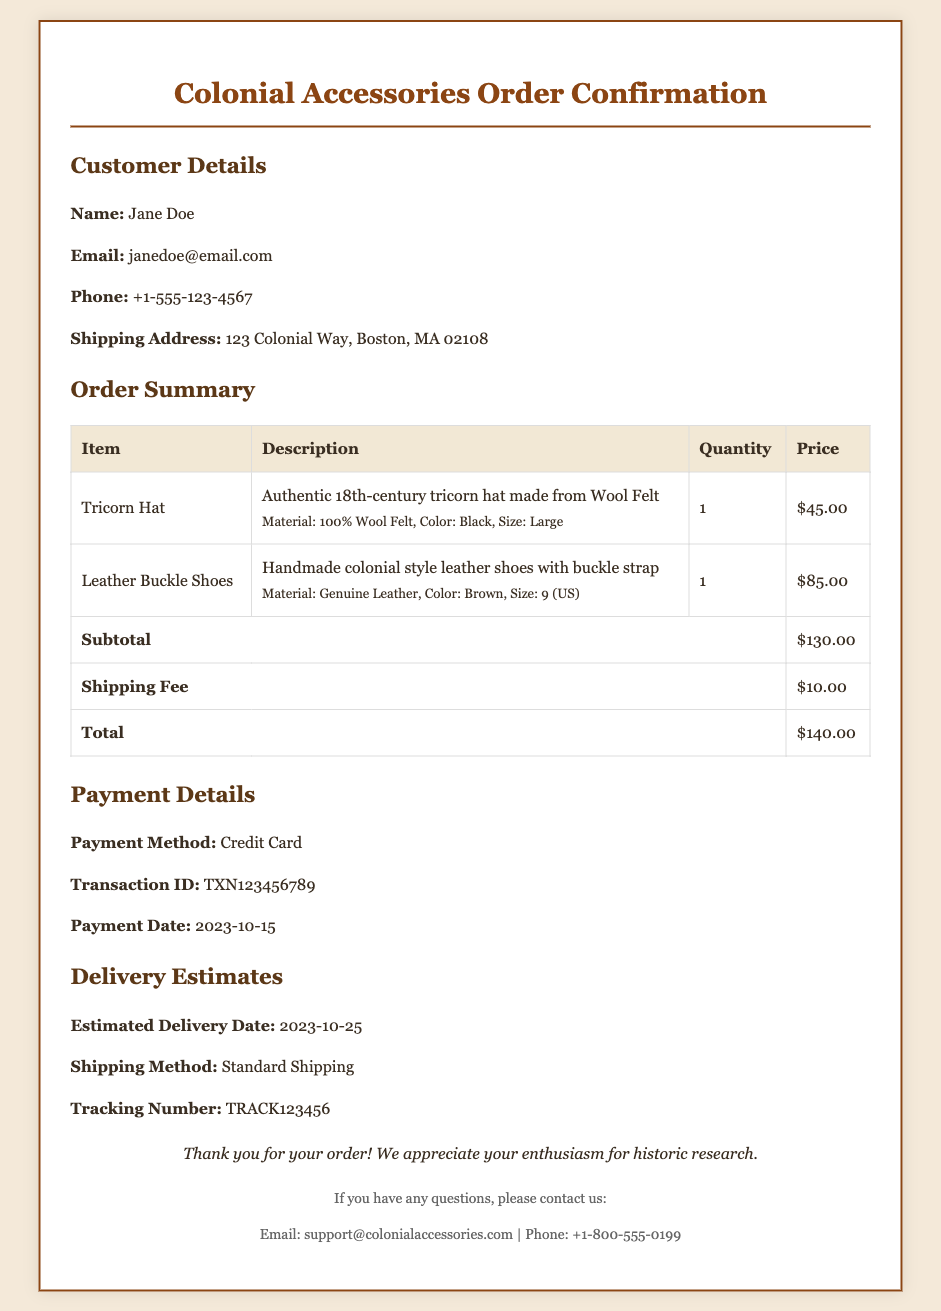What is the total price of the order? The total price is listed in the order summary, which includes the subtotal and shipping fee.
Answer: $140.00 What is the estimated delivery date? The estimated delivery date is provided under the delivery estimates section of the document.
Answer: 2023-10-25 How many Tricorn Hats were ordered? The quantity of Tricorn Hats is specified in the order summary table.
Answer: 1 What material is used for the Leather Buckle Shoes? The material for the Leather Buckle Shoes is detailed in the description of the item in the order summary.
Answer: Genuine Leather Who should be contacted for questions about the order? The contact information provided at the bottom of the document specifies whom to contact for questions.
Answer: support@colonialaccessories.com What is the shipping method listed in the document? The shipping method is explicitly stated in the delivery estimates section.
Answer: Standard Shipping What is the color of the Tricorn Hat? The color of the Tricorn Hat is mentioned in the item's description within the order summary table.
Answer: Black What payment method was used for the transaction? The payment method can be found in the payment details section of the document.
Answer: Credit Card 